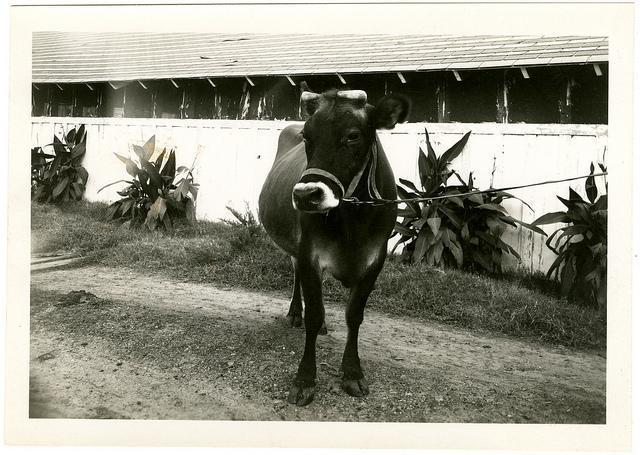How many potted plants can you see?
Give a very brief answer. 4. How many people are wearing glasses?
Give a very brief answer. 0. 